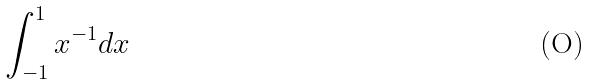<formula> <loc_0><loc_0><loc_500><loc_500>\int _ { - 1 } ^ { 1 } x ^ { - 1 } d x</formula> 